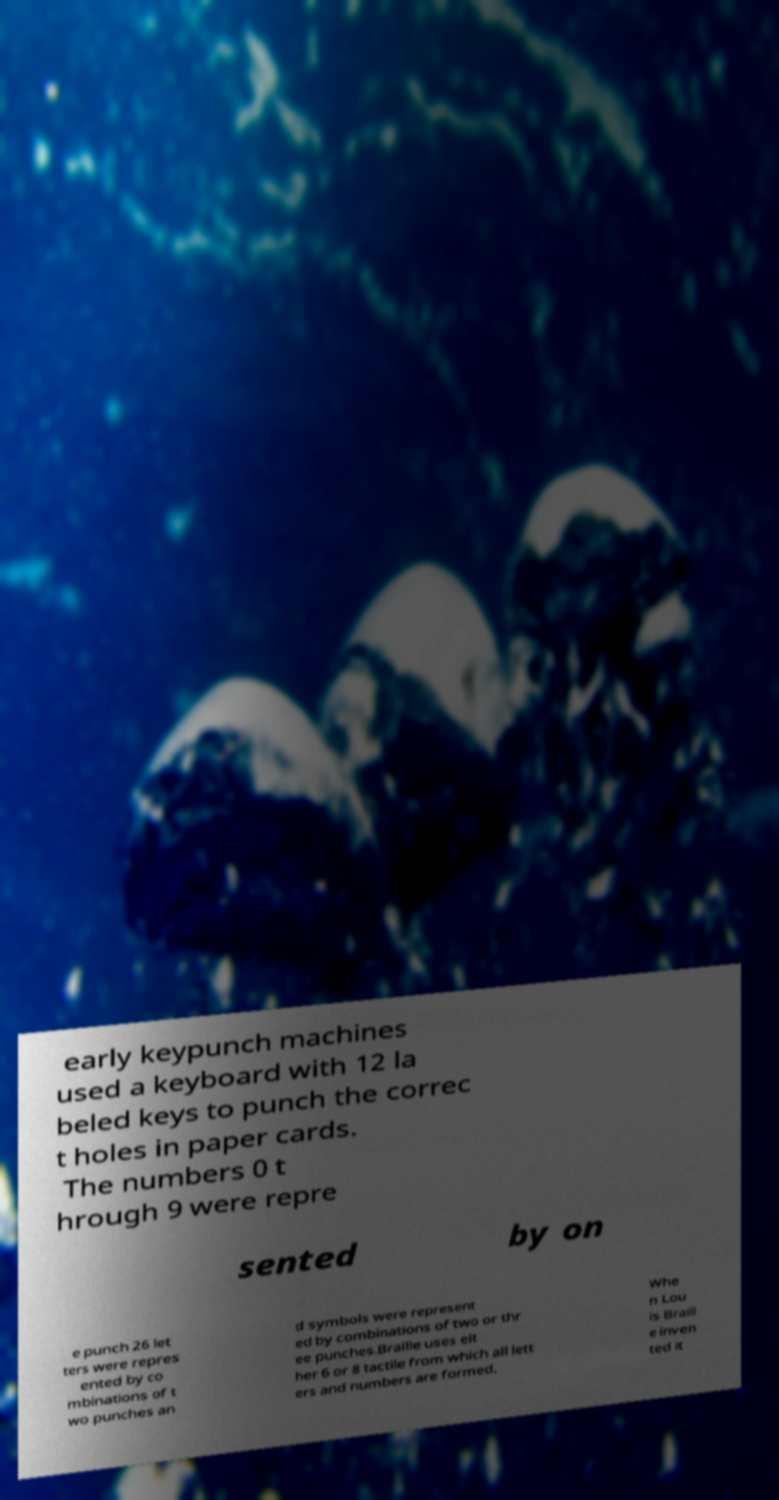Could you extract and type out the text from this image? early keypunch machines used a keyboard with 12 la beled keys to punch the correc t holes in paper cards. The numbers 0 t hrough 9 were repre sented by on e punch 26 let ters were repres ented by co mbinations of t wo punches an d symbols were represent ed by combinations of two or thr ee punches.Braille uses eit her 6 or 8 tactile from which all lett ers and numbers are formed. Whe n Lou is Braill e inven ted it 